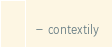<code> <loc_0><loc_0><loc_500><loc_500><_YAML_>  - contextily


</code> 